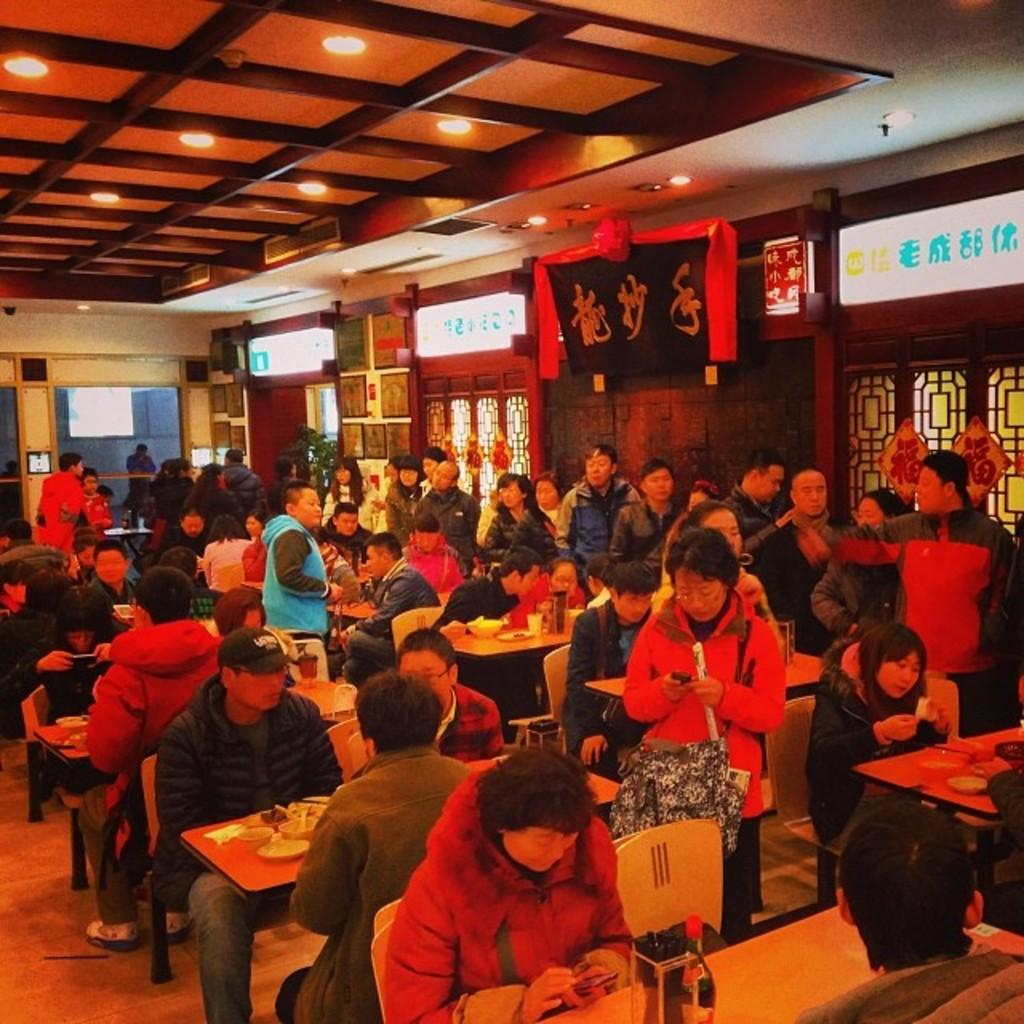What are the people in the image doing? There are people sitting at tables and standing in the image. Where is this scene taking place? The setting is a restaurant. What type of coach can be seen in the image? There is no coach present in the image; it is set in a restaurant. How does the feeling of the people in the image affect their throat? There is no information about the feelings of the people in the image, and therefore we cannot determine any effect on their throats. 